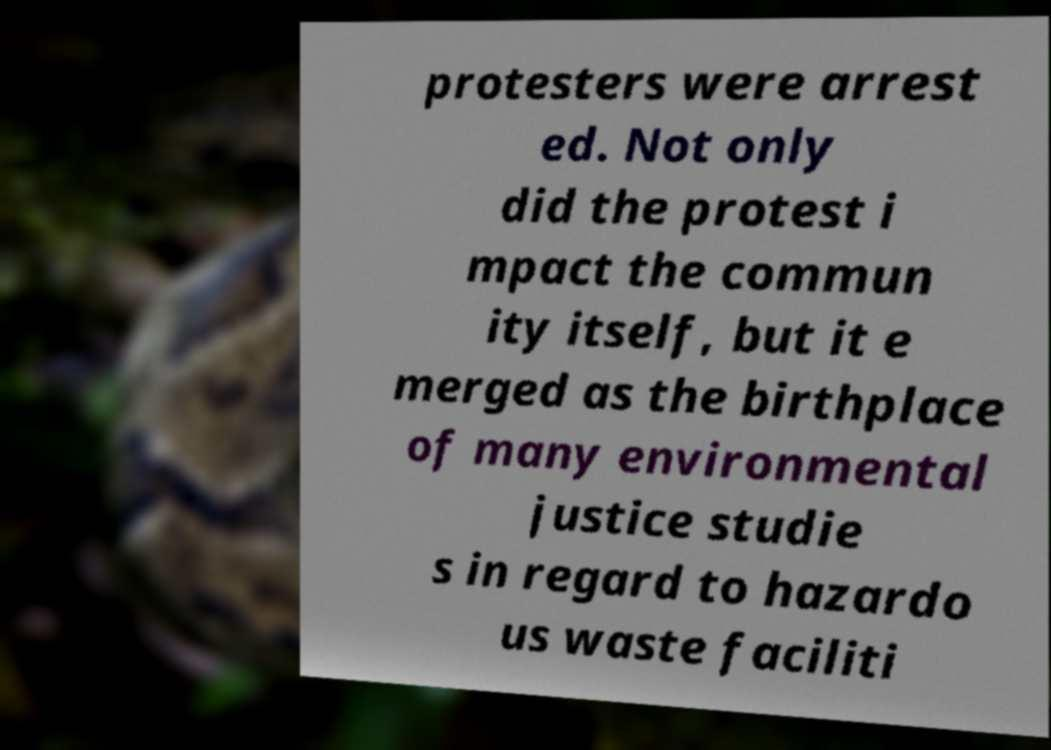I need the written content from this picture converted into text. Can you do that? protesters were arrest ed. Not only did the protest i mpact the commun ity itself, but it e merged as the birthplace of many environmental justice studie s in regard to hazardo us waste faciliti 